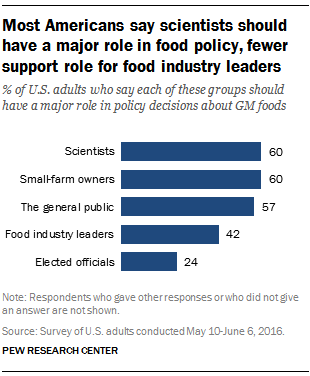Point out several critical features in this image. Scientists' bar has a percentage of 60. The ratio between scientists and small-farm owners is 1. 